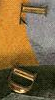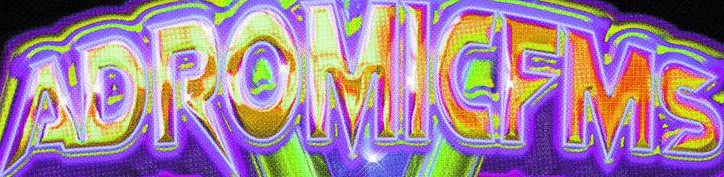What words can you see in these images in sequence, separated by a semicolon? LD; ADROMICFMS 